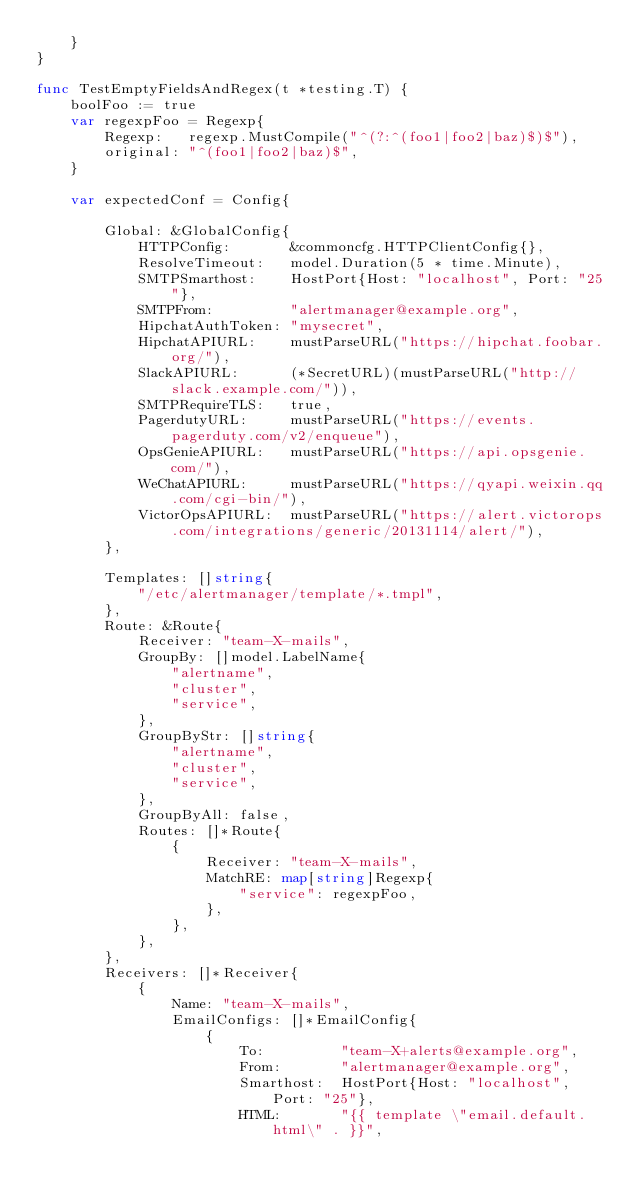Convert code to text. <code><loc_0><loc_0><loc_500><loc_500><_Go_>	}
}

func TestEmptyFieldsAndRegex(t *testing.T) {
	boolFoo := true
	var regexpFoo = Regexp{
		Regexp:   regexp.MustCompile("^(?:^(foo1|foo2|baz)$)$"),
		original: "^(foo1|foo2|baz)$",
	}

	var expectedConf = Config{

		Global: &GlobalConfig{
			HTTPConfig:       &commoncfg.HTTPClientConfig{},
			ResolveTimeout:   model.Duration(5 * time.Minute),
			SMTPSmarthost:    HostPort{Host: "localhost", Port: "25"},
			SMTPFrom:         "alertmanager@example.org",
			HipchatAuthToken: "mysecret",
			HipchatAPIURL:    mustParseURL("https://hipchat.foobar.org/"),
			SlackAPIURL:      (*SecretURL)(mustParseURL("http://slack.example.com/")),
			SMTPRequireTLS:   true,
			PagerdutyURL:     mustParseURL("https://events.pagerduty.com/v2/enqueue"),
			OpsGenieAPIURL:   mustParseURL("https://api.opsgenie.com/"),
			WeChatAPIURL:     mustParseURL("https://qyapi.weixin.qq.com/cgi-bin/"),
			VictorOpsAPIURL:  mustParseURL("https://alert.victorops.com/integrations/generic/20131114/alert/"),
		},

		Templates: []string{
			"/etc/alertmanager/template/*.tmpl",
		},
		Route: &Route{
			Receiver: "team-X-mails",
			GroupBy: []model.LabelName{
				"alertname",
				"cluster",
				"service",
			},
			GroupByStr: []string{
				"alertname",
				"cluster",
				"service",
			},
			GroupByAll: false,
			Routes: []*Route{
				{
					Receiver: "team-X-mails",
					MatchRE: map[string]Regexp{
						"service": regexpFoo,
					},
				},
			},
		},
		Receivers: []*Receiver{
			{
				Name: "team-X-mails",
				EmailConfigs: []*EmailConfig{
					{
						To:         "team-X+alerts@example.org",
						From:       "alertmanager@example.org",
						Smarthost:  HostPort{Host: "localhost", Port: "25"},
						HTML:       "{{ template \"email.default.html\" . }}",</code> 